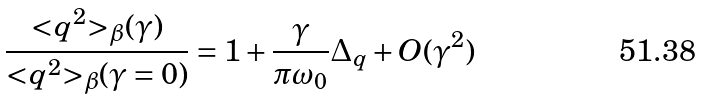<formula> <loc_0><loc_0><loc_500><loc_500>\frac { { < } q ^ { 2 } { > } _ { \beta } ( \gamma ) } { { < } q ^ { 2 } { > } _ { \beta } ( \gamma = 0 ) } = 1 + \frac { \gamma } { \pi \omega _ { 0 } } \Delta _ { q } + O ( \gamma ^ { 2 } )</formula> 